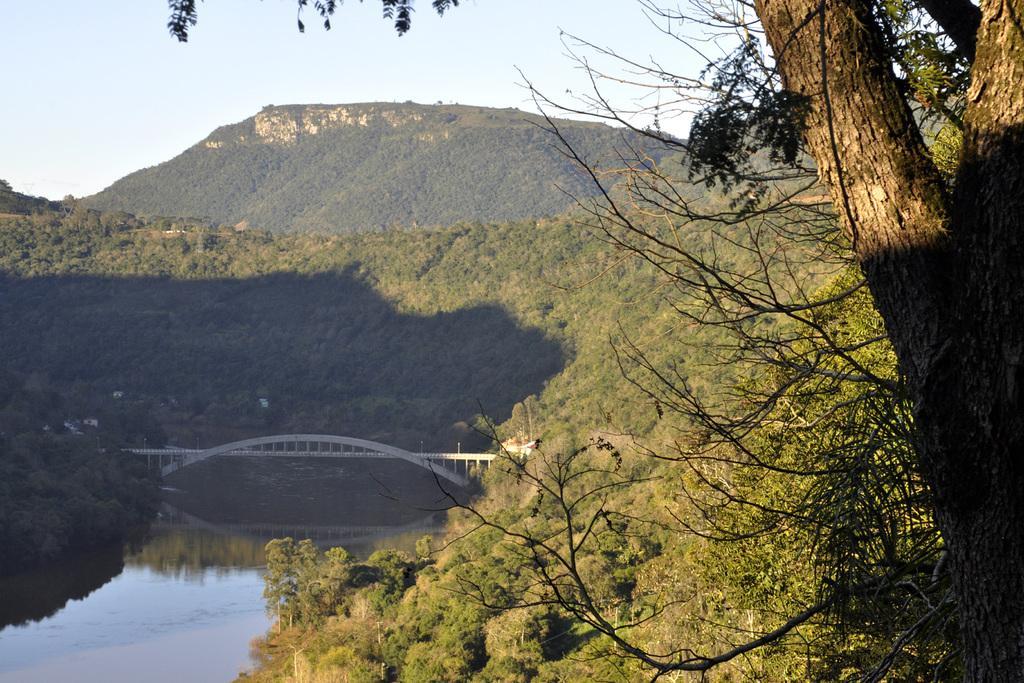Please provide a concise description of this image. In this image we can see the hills, trees, bridge, water and also the sky. 